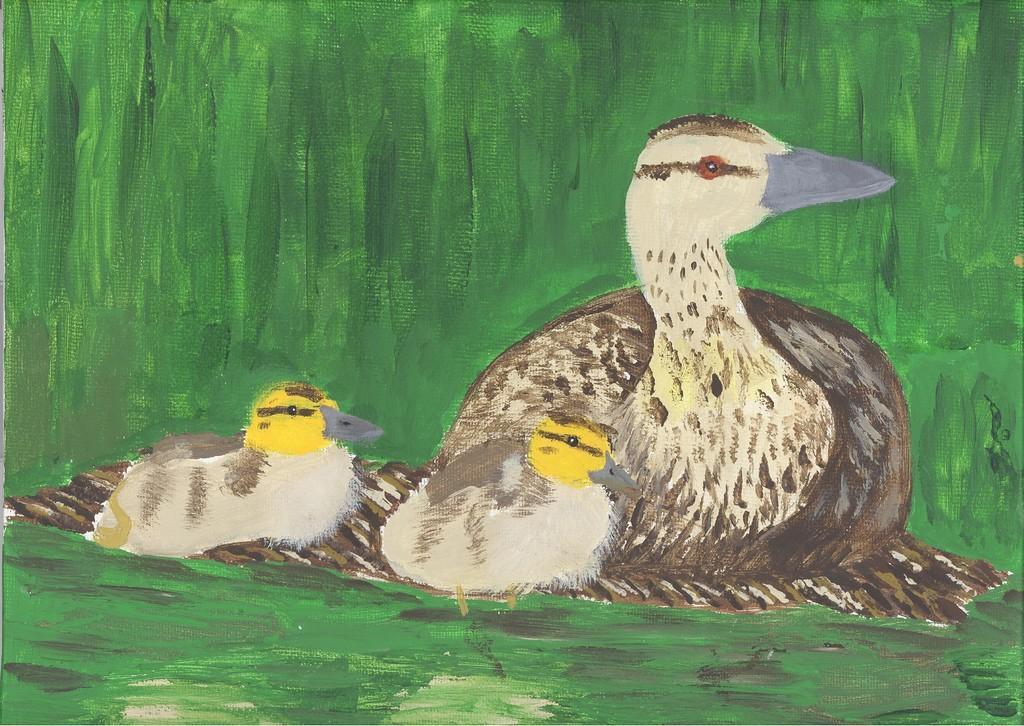Could you give a brief overview of what you see in this image? In the image we can see there is a painting of duck with her ducklings. 